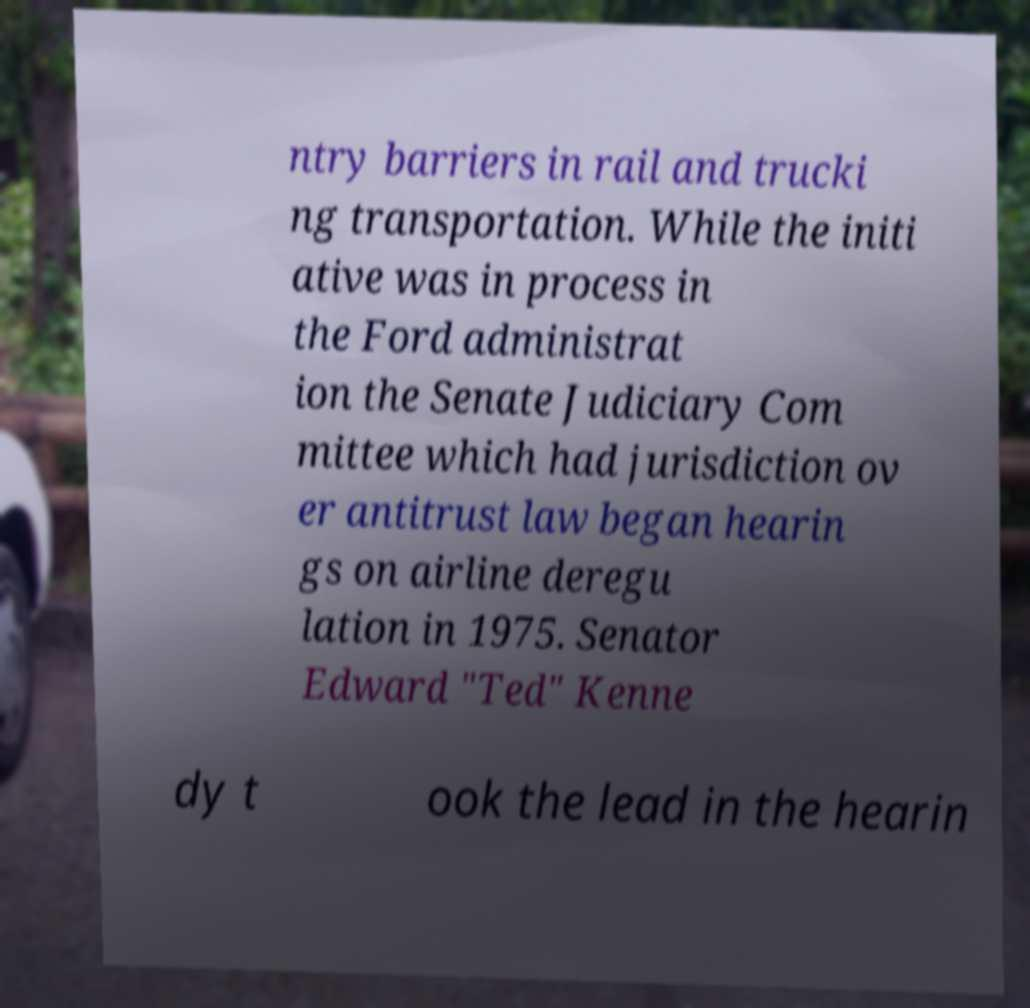For documentation purposes, I need the text within this image transcribed. Could you provide that? ntry barriers in rail and trucki ng transportation. While the initi ative was in process in the Ford administrat ion the Senate Judiciary Com mittee which had jurisdiction ov er antitrust law began hearin gs on airline deregu lation in 1975. Senator Edward "Ted" Kenne dy t ook the lead in the hearin 